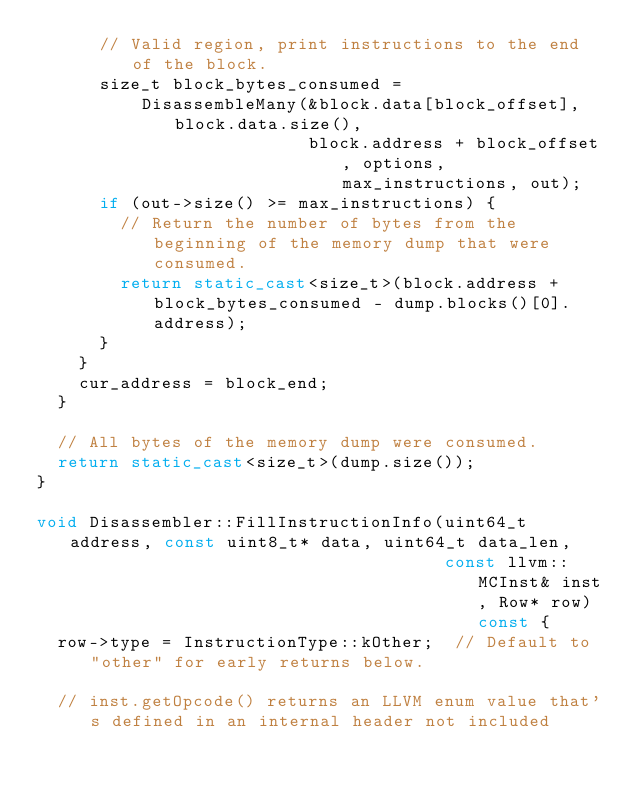Convert code to text. <code><loc_0><loc_0><loc_500><loc_500><_C++_>      // Valid region, print instructions to the end of the block.
      size_t block_bytes_consumed =
          DisassembleMany(&block.data[block_offset], block.data.size(),
                          block.address + block_offset, options, max_instructions, out);
      if (out->size() >= max_instructions) {
        // Return the number of bytes from the beginning of the memory dump that were consumed.
        return static_cast<size_t>(block.address + block_bytes_consumed - dump.blocks()[0].address);
      }
    }
    cur_address = block_end;
  }

  // All bytes of the memory dump were consumed.
  return static_cast<size_t>(dump.size());
}

void Disassembler::FillInstructionInfo(uint64_t address, const uint8_t* data, uint64_t data_len,
                                       const llvm::MCInst& inst, Row* row) const {
  row->type = InstructionType::kOther;  // Default to "other" for early returns below.

  // inst.getOpcode() returns an LLVM enum value that's defined in an internal header not included</code> 